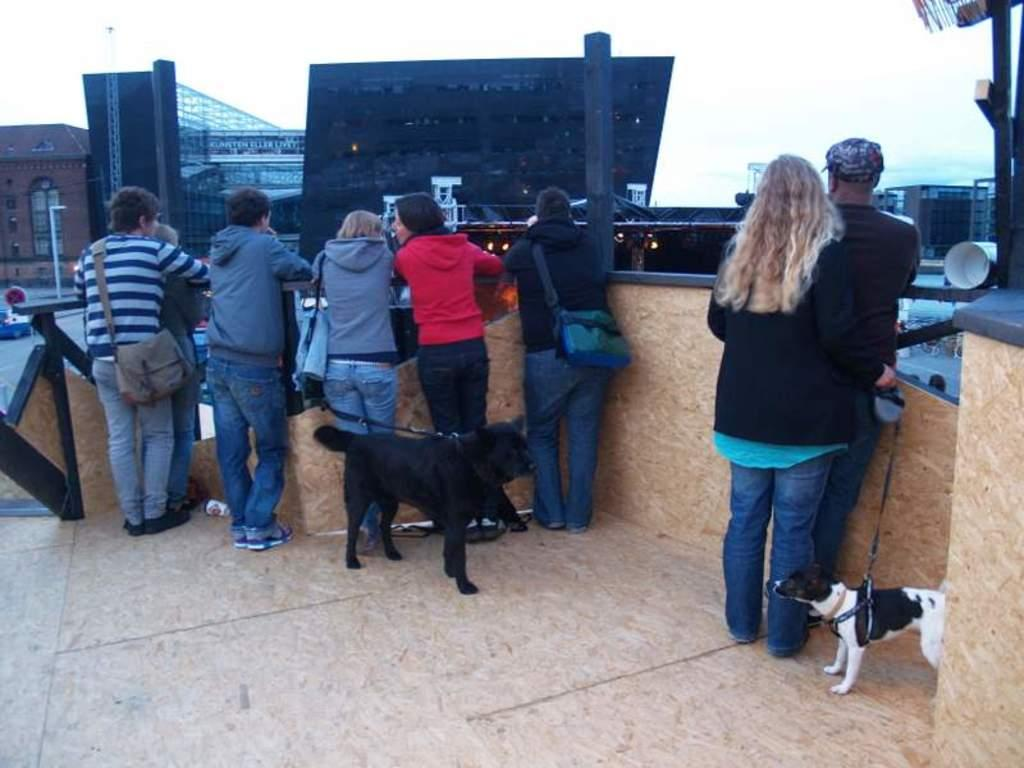Who is present in the image? There are people in the image. What are the people holding in the image? The people are holding belts in the image. What are the people doing with the belts? The people are controlling dogs with the belts. How many dogs are in the image? There are two dogs in the image. What are the dogs and people looking at? The dogs and people are looking at an opposite building. Where can we find the dad in the image? There is no mention of a dad in the image, so we cannot determine his location. 